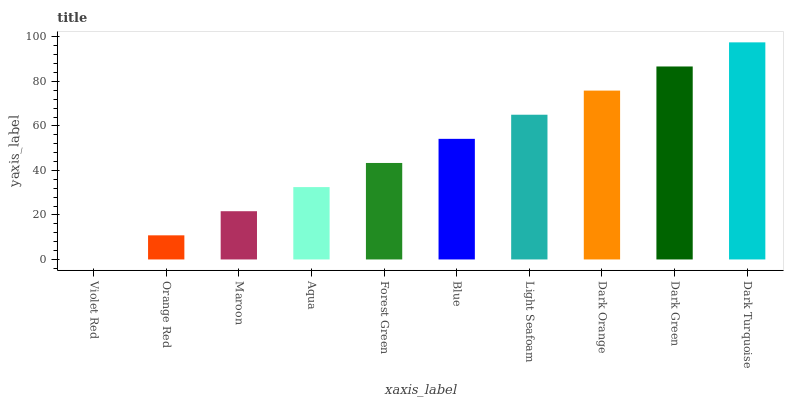Is Violet Red the minimum?
Answer yes or no. Yes. Is Dark Turquoise the maximum?
Answer yes or no. Yes. Is Orange Red the minimum?
Answer yes or no. No. Is Orange Red the maximum?
Answer yes or no. No. Is Orange Red greater than Violet Red?
Answer yes or no. Yes. Is Violet Red less than Orange Red?
Answer yes or no. Yes. Is Violet Red greater than Orange Red?
Answer yes or no. No. Is Orange Red less than Violet Red?
Answer yes or no. No. Is Blue the high median?
Answer yes or no. Yes. Is Forest Green the low median?
Answer yes or no. Yes. Is Light Seafoam the high median?
Answer yes or no. No. Is Dark Turquoise the low median?
Answer yes or no. No. 